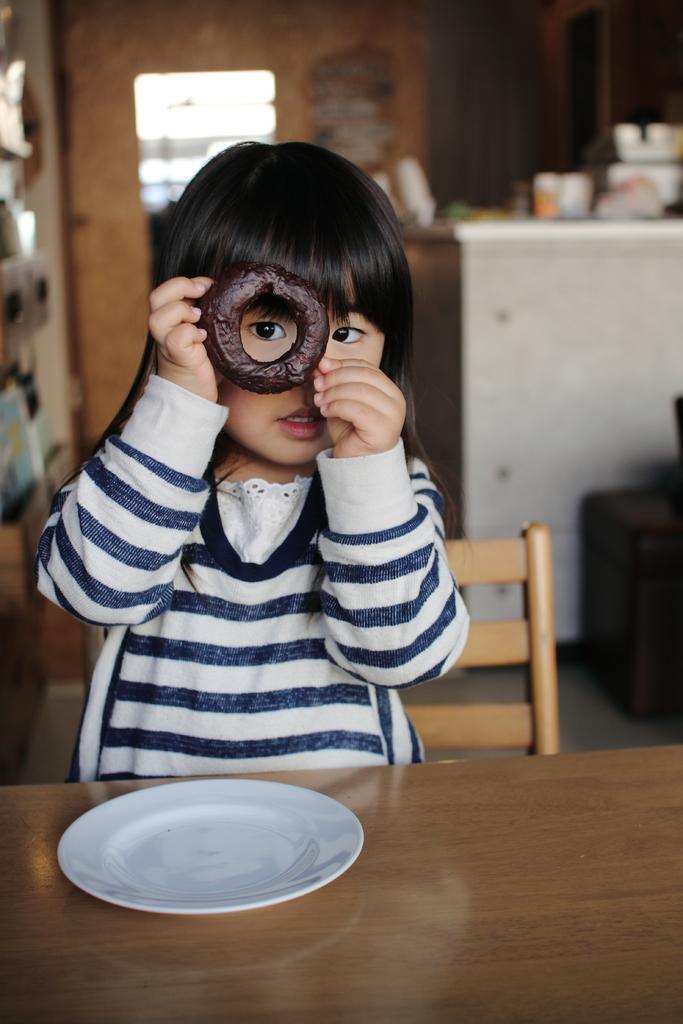In one or two sentences, can you explain what this image depicts? in this image i can see a plate on the table. there is a girl sitting on the chair holding a donut in her hand 